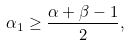Convert formula to latex. <formula><loc_0><loc_0><loc_500><loc_500>\alpha _ { 1 } \geq \frac { \alpha + \beta - 1 } { 2 } ,</formula> 